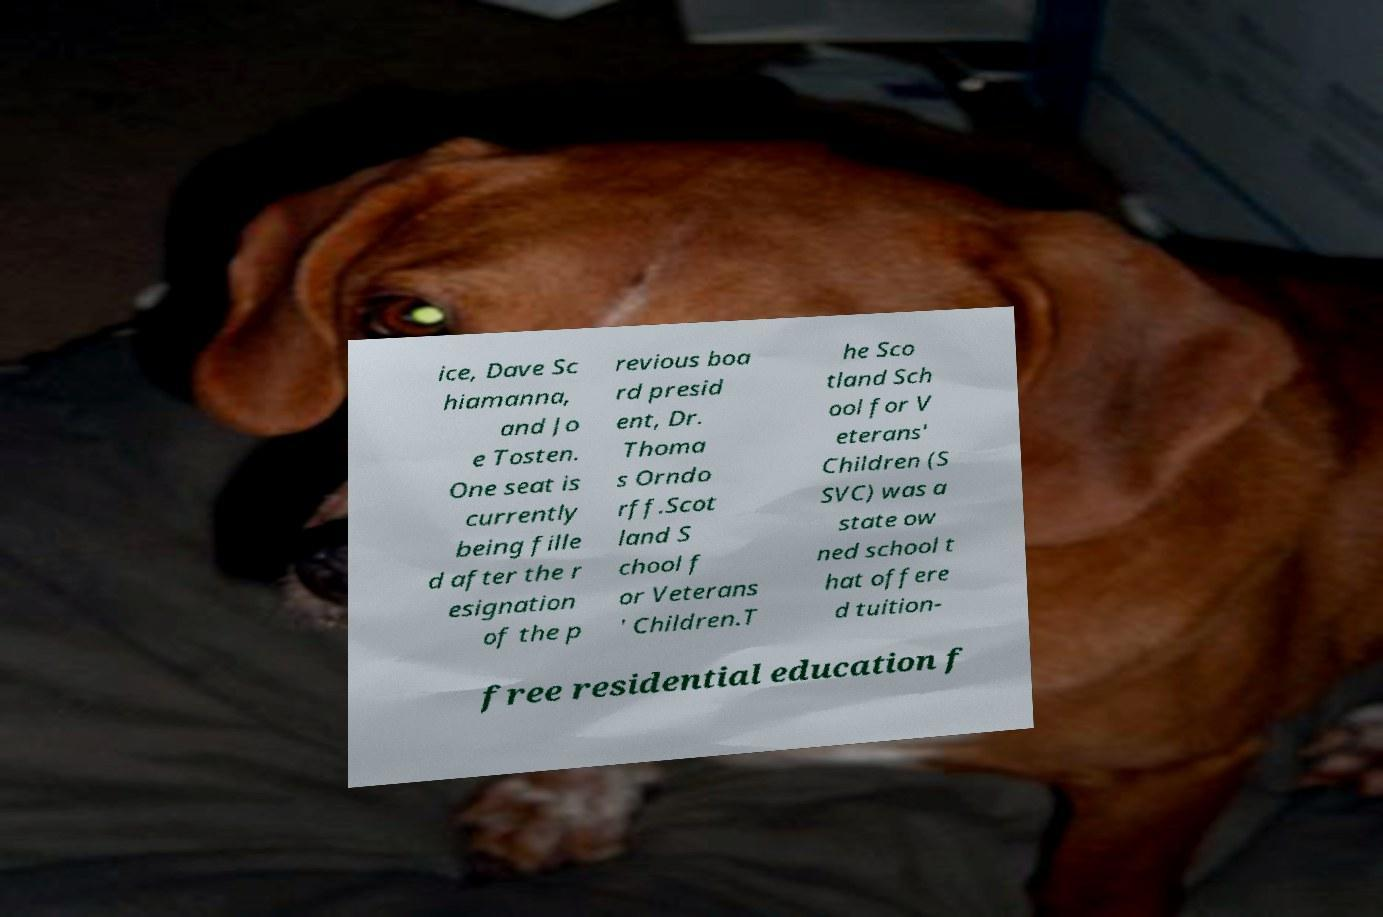Can you read and provide the text displayed in the image?This photo seems to have some interesting text. Can you extract and type it out for me? ice, Dave Sc hiamanna, and Jo e Tosten. One seat is currently being fille d after the r esignation of the p revious boa rd presid ent, Dr. Thoma s Orndo rff.Scot land S chool f or Veterans ' Children.T he Sco tland Sch ool for V eterans' Children (S SVC) was a state ow ned school t hat offere d tuition- free residential education f 